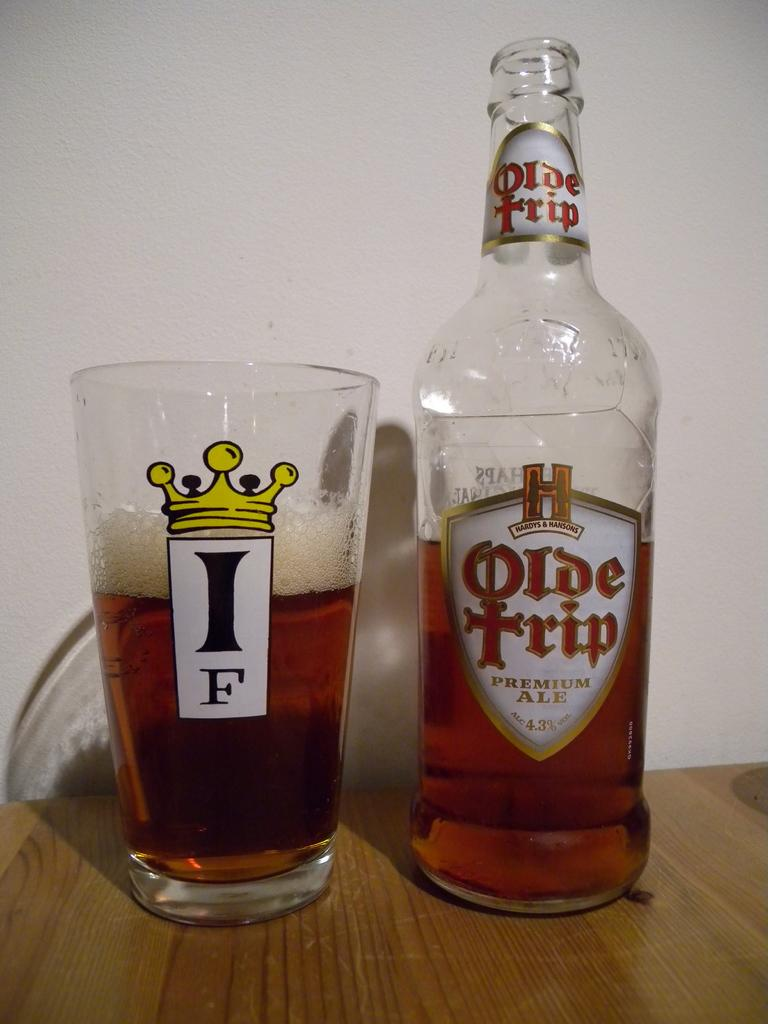What is on the table in the image? There is a glass and a bottle on the table in the image. What is inside the bottle? There is water in the bottle. What is inside the glass? There is water in the glass. Is there any additional information about the bottle? Yes, there is a sticker on the bottle. What degree does the queen hold in the image? There is no queen present in the image, so it is not possible to determine what degree she might hold. 